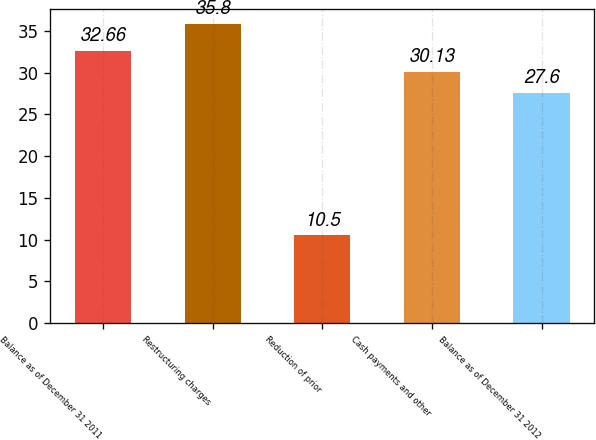<chart> <loc_0><loc_0><loc_500><loc_500><bar_chart><fcel>Balance as of December 31 2011<fcel>Restructuring charges<fcel>Reduction of prior<fcel>Cash payments and other<fcel>Balance as of December 31 2012<nl><fcel>32.66<fcel>35.8<fcel>10.5<fcel>30.13<fcel>27.6<nl></chart> 